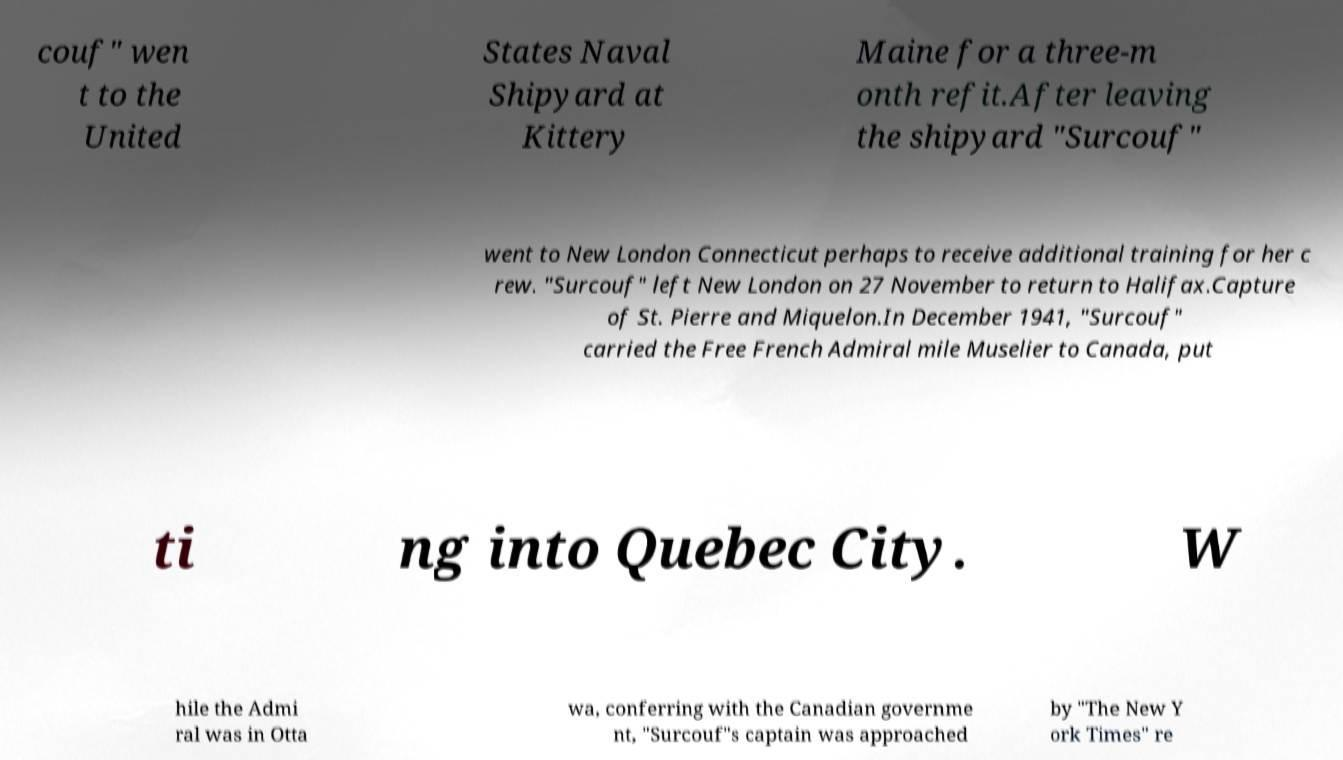What messages or text are displayed in this image? I need them in a readable, typed format. couf" wen t to the United States Naval Shipyard at Kittery Maine for a three-m onth refit.After leaving the shipyard "Surcouf" went to New London Connecticut perhaps to receive additional training for her c rew. "Surcouf" left New London on 27 November to return to Halifax.Capture of St. Pierre and Miquelon.In December 1941, "Surcouf" carried the Free French Admiral mile Muselier to Canada, put ti ng into Quebec City. W hile the Admi ral was in Otta wa, conferring with the Canadian governme nt, "Surcouf"s captain was approached by "The New Y ork Times" re 